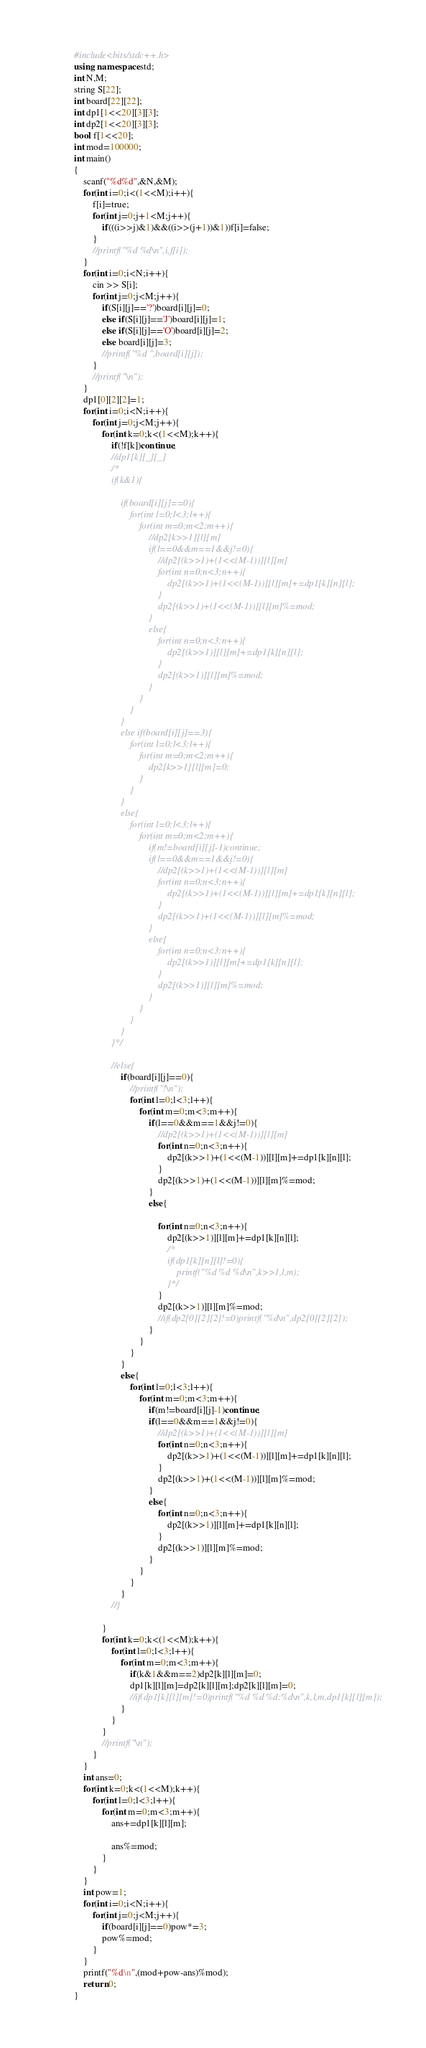<code> <loc_0><loc_0><loc_500><loc_500><_C++_>#include<bits/stdc++.h>
using namespace std;
int N,M;
string S[22];
int board[22][22];
int dp1[1<<20][3][3];
int dp2[1<<20][3][3];
bool f[1<<20];
int mod=100000;
int main()
{
	scanf("%d%d",&N,&M);
	for(int i=0;i<(1<<M);i++){
		f[i]=true;
		for(int j=0;j+1<M;j++){
			if(((i>>j)&1)&&((i>>(j+1))&1))f[i]=false;
		}
		//printf("%d %d\n",i,f[i]);
	}
	for(int i=0;i<N;i++){
		cin >> S[i];
		for(int j=0;j<M;j++){
			if(S[i][j]=='?')board[i][j]=0;
			else if(S[i][j]=='J')board[i][j]=1;
			else if(S[i][j]=='O')board[i][j]=2;
			else board[i][j]=3;
			//printf("%d ",board[i][j]);
		}
		//printf("\n");
	}
	dp1[0][2][2]=1;
	for(int i=0;i<N;i++){
		for(int j=0;j<M;j++){
			for(int k=0;k<(1<<M);k++){
				if(!f[k])continue;
				//dp1[k][_][_]
				/*
				if(k&1){
					
					if(board[i][j]==0){
						for(int l=0;l<3;l++){
							for(int m=0;m<2;m++){
								//dp2[k>>1][l][m]
								if(l==0&&m==1&&j!=0){
									//dp2[(k>>1)+(1<<(M-1))][l][m]
									for(int n=0;n<3;n++){
										dp2[(k>>1)+(1<<(M-1))][l][m]+=dp1[k][n][l];
									}
									dp2[(k>>1)+(1<<(M-1))][l][m]%=mod;
								}
								else{
									for(int n=0;n<3;n++){
										dp2[(k>>1)][l][m]+=dp1[k][n][l];
									}
									dp2[(k>>1)][l][m]%=mod;
								}
							}
						}
					}
					else if(board[i][j]==3){
						for(int l=0;l<3;l++){
							for(int m=0;m<2;m++){
								dp2[k>>1][l][m]=0;
							}
						}
					}
					else{
						for(int l=0;l<3;l++){
							for(int m=0;m<2;m++){
								if(m!=board[i][j]-1)continue;
								if(l==0&&m==1&&j!=0){
									//dp2[(k>>1)+(1<<(M-1))][l][m]
									for(int n=0;n<3;n++){
										dp2[(k>>1)+(1<<(M-1))][l][m]+=dp1[k][n][l];
									}
									dp2[(k>>1)+(1<<(M-1))][l][m]%=mod;
								}
								else{
									for(int n=0;n<3;n++){
										dp2[(k>>1)][l][m]+=dp1[k][n][l];
									}
									dp2[(k>>1)][l][m]%=mod;
								}
							}
						}
					}
				}*/
				
				//else{
					if(board[i][j]==0){
						//printf("!\n");
						for(int l=0;l<3;l++){
							for(int m=0;m<3;m++){
								if(l==0&&m==1&&j!=0){
									//dp2[(k>>1)+(1<<(M-1))][l][m]
									for(int n=0;n<3;n++){
										dp2[(k>>1)+(1<<(M-1))][l][m]+=dp1[k][n][l];
									}
									dp2[(k>>1)+(1<<(M-1))][l][m]%=mod;
								}
								else{
									
									for(int n=0;n<3;n++){
										dp2[(k>>1)][l][m]+=dp1[k][n][l];
										/*
										if(dp1[k][n][l]!=0){
											printf("%d %d %d\n",k>>1,l,m);
										}*/
									}
									dp2[(k>>1)][l][m]%=mod;
									//if(dp2[0][2][2]!=0)printf("%d\n",dp2[0][2][2]);
								}
							}
						}
					}
					else{
						for(int l=0;l<3;l++){
							for(int m=0;m<3;m++){
								if(m!=board[i][j]-1)continue;
								if(l==0&&m==1&&j!=0){
									//dp2[(k>>1)+(1<<(M-1))][l][m]
									for(int n=0;n<3;n++){
										dp2[(k>>1)+(1<<(M-1))][l][m]+=dp1[k][n][l];
									}
									dp2[(k>>1)+(1<<(M-1))][l][m]%=mod;
								}
								else{
									for(int n=0;n<3;n++){
										dp2[(k>>1)][l][m]+=dp1[k][n][l];
									}
									dp2[(k>>1)][l][m]%=mod;
								}
							}
						}
					}
				//}
				
			}
			for(int k=0;k<(1<<M);k++){
				for(int l=0;l<3;l++){
					for(int m=0;m<3;m++){
						if(k&1&&m==2)dp2[k][l][m]=0;
						dp1[k][l][m]=dp2[k][l][m];dp2[k][l][m]=0;
						//if(dp1[k][l][m]!=0)printf("%d %d %d:%d\n",k,l,m,dp1[k][l][m]);
					}
				}
			}
			//printf("\n");
		}
	}
	int ans=0;
	for(int k=0;k<(1<<M);k++){
		for(int l=0;l<3;l++){
			for(int m=0;m<3;m++){
				ans+=dp1[k][l][m];
				
				ans%=mod;
			}
		}
	}
	int pow=1;
	for(int i=0;i<N;i++){
		for(int j=0;j<M;j++){
			if(board[i][j]==0)pow*=3;
			pow%=mod;
		}
	}
	printf("%d\n",(mod+pow-ans)%mod);
	return 0;
}</code> 